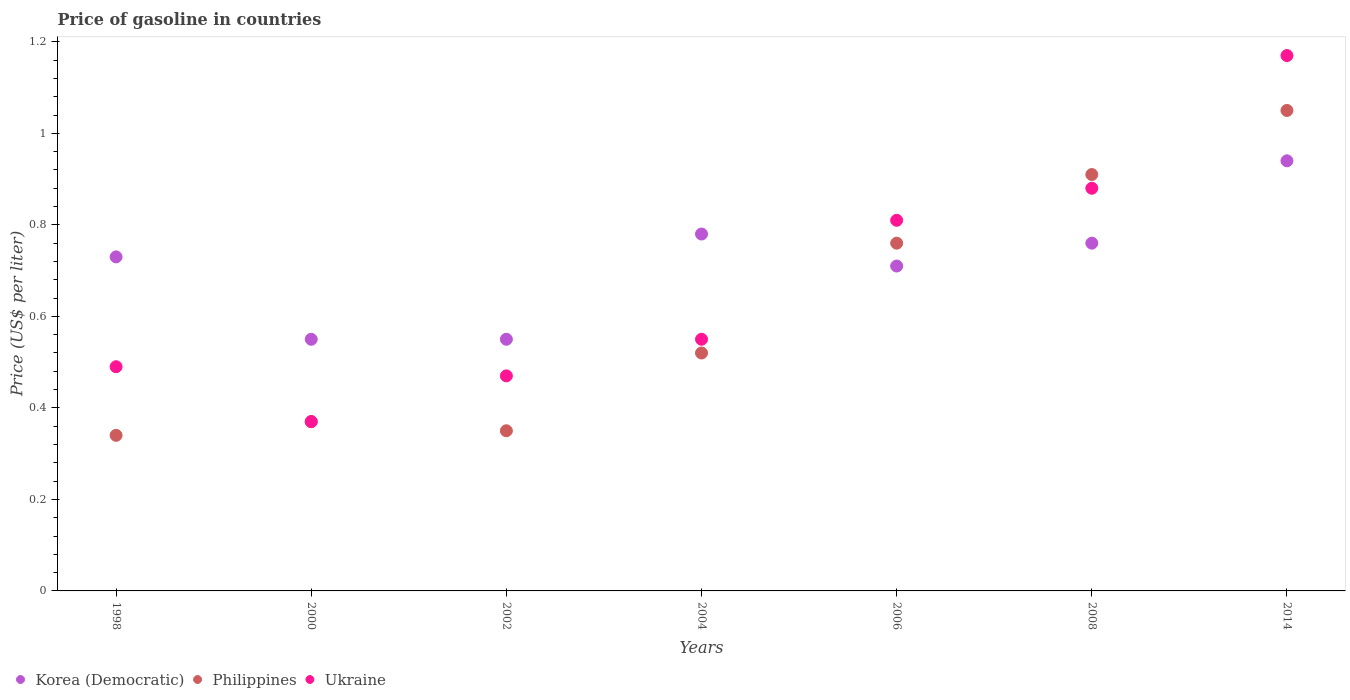How many different coloured dotlines are there?
Provide a succinct answer. 3. Is the number of dotlines equal to the number of legend labels?
Give a very brief answer. Yes. What is the price of gasoline in Korea (Democratic) in 2006?
Your answer should be very brief. 0.71. Across all years, what is the maximum price of gasoline in Philippines?
Offer a very short reply. 1.05. Across all years, what is the minimum price of gasoline in Korea (Democratic)?
Your answer should be very brief. 0.55. What is the total price of gasoline in Philippines in the graph?
Offer a very short reply. 4.3. What is the difference between the price of gasoline in Philippines in 1998 and that in 2014?
Your answer should be very brief. -0.71. What is the difference between the price of gasoline in Korea (Democratic) in 2006 and the price of gasoline in Philippines in 2008?
Provide a short and direct response. -0.2. What is the average price of gasoline in Philippines per year?
Make the answer very short. 0.61. In the year 1998, what is the difference between the price of gasoline in Philippines and price of gasoline in Korea (Democratic)?
Make the answer very short. -0.39. In how many years, is the price of gasoline in Philippines greater than 0.9600000000000001 US$?
Offer a terse response. 1. What is the ratio of the price of gasoline in Philippines in 1998 to that in 2006?
Your answer should be very brief. 0.45. What is the difference between the highest and the second highest price of gasoline in Korea (Democratic)?
Give a very brief answer. 0.16. What is the difference between the highest and the lowest price of gasoline in Korea (Democratic)?
Your response must be concise. 0.39. In how many years, is the price of gasoline in Korea (Democratic) greater than the average price of gasoline in Korea (Democratic) taken over all years?
Offer a terse response. 4. Is it the case that in every year, the sum of the price of gasoline in Ukraine and price of gasoline in Korea (Democratic)  is greater than the price of gasoline in Philippines?
Keep it short and to the point. Yes. Is the price of gasoline in Ukraine strictly less than the price of gasoline in Philippines over the years?
Offer a terse response. No. How many dotlines are there?
Your response must be concise. 3. How many years are there in the graph?
Offer a terse response. 7. What is the difference between two consecutive major ticks on the Y-axis?
Provide a short and direct response. 0.2. How are the legend labels stacked?
Offer a terse response. Horizontal. What is the title of the graph?
Give a very brief answer. Price of gasoline in countries. Does "Tanzania" appear as one of the legend labels in the graph?
Offer a very short reply. No. What is the label or title of the Y-axis?
Offer a very short reply. Price (US$ per liter). What is the Price (US$ per liter) of Korea (Democratic) in 1998?
Ensure brevity in your answer.  0.73. What is the Price (US$ per liter) of Philippines in 1998?
Offer a terse response. 0.34. What is the Price (US$ per liter) of Ukraine in 1998?
Offer a terse response. 0.49. What is the Price (US$ per liter) in Korea (Democratic) in 2000?
Your answer should be very brief. 0.55. What is the Price (US$ per liter) in Philippines in 2000?
Provide a succinct answer. 0.37. What is the Price (US$ per liter) of Ukraine in 2000?
Offer a very short reply. 0.37. What is the Price (US$ per liter) in Korea (Democratic) in 2002?
Ensure brevity in your answer.  0.55. What is the Price (US$ per liter) in Philippines in 2002?
Provide a short and direct response. 0.35. What is the Price (US$ per liter) of Ukraine in 2002?
Make the answer very short. 0.47. What is the Price (US$ per liter) in Korea (Democratic) in 2004?
Your answer should be very brief. 0.78. What is the Price (US$ per liter) of Philippines in 2004?
Your answer should be compact. 0.52. What is the Price (US$ per liter) in Ukraine in 2004?
Provide a succinct answer. 0.55. What is the Price (US$ per liter) in Korea (Democratic) in 2006?
Offer a terse response. 0.71. What is the Price (US$ per liter) of Philippines in 2006?
Offer a terse response. 0.76. What is the Price (US$ per liter) of Ukraine in 2006?
Your answer should be very brief. 0.81. What is the Price (US$ per liter) of Korea (Democratic) in 2008?
Give a very brief answer. 0.76. What is the Price (US$ per liter) in Philippines in 2008?
Ensure brevity in your answer.  0.91. What is the Price (US$ per liter) in Korea (Democratic) in 2014?
Your answer should be very brief. 0.94. What is the Price (US$ per liter) in Philippines in 2014?
Offer a very short reply. 1.05. What is the Price (US$ per liter) in Ukraine in 2014?
Provide a short and direct response. 1.17. Across all years, what is the maximum Price (US$ per liter) of Philippines?
Provide a short and direct response. 1.05. Across all years, what is the maximum Price (US$ per liter) of Ukraine?
Your response must be concise. 1.17. Across all years, what is the minimum Price (US$ per liter) in Korea (Democratic)?
Provide a succinct answer. 0.55. Across all years, what is the minimum Price (US$ per liter) of Philippines?
Keep it short and to the point. 0.34. Across all years, what is the minimum Price (US$ per liter) in Ukraine?
Offer a terse response. 0.37. What is the total Price (US$ per liter) of Korea (Democratic) in the graph?
Provide a succinct answer. 5.02. What is the total Price (US$ per liter) of Ukraine in the graph?
Make the answer very short. 4.74. What is the difference between the Price (US$ per liter) in Korea (Democratic) in 1998 and that in 2000?
Offer a very short reply. 0.18. What is the difference between the Price (US$ per liter) in Philippines in 1998 and that in 2000?
Your answer should be very brief. -0.03. What is the difference between the Price (US$ per liter) in Ukraine in 1998 and that in 2000?
Provide a short and direct response. 0.12. What is the difference between the Price (US$ per liter) of Korea (Democratic) in 1998 and that in 2002?
Your answer should be compact. 0.18. What is the difference between the Price (US$ per liter) in Philippines in 1998 and that in 2002?
Give a very brief answer. -0.01. What is the difference between the Price (US$ per liter) in Ukraine in 1998 and that in 2002?
Your response must be concise. 0.02. What is the difference between the Price (US$ per liter) in Korea (Democratic) in 1998 and that in 2004?
Give a very brief answer. -0.05. What is the difference between the Price (US$ per liter) in Philippines in 1998 and that in 2004?
Give a very brief answer. -0.18. What is the difference between the Price (US$ per liter) in Ukraine in 1998 and that in 2004?
Make the answer very short. -0.06. What is the difference between the Price (US$ per liter) in Korea (Democratic) in 1998 and that in 2006?
Offer a very short reply. 0.02. What is the difference between the Price (US$ per liter) of Philippines in 1998 and that in 2006?
Keep it short and to the point. -0.42. What is the difference between the Price (US$ per liter) of Ukraine in 1998 and that in 2006?
Offer a terse response. -0.32. What is the difference between the Price (US$ per liter) of Korea (Democratic) in 1998 and that in 2008?
Offer a terse response. -0.03. What is the difference between the Price (US$ per liter) in Philippines in 1998 and that in 2008?
Ensure brevity in your answer.  -0.57. What is the difference between the Price (US$ per liter) in Ukraine in 1998 and that in 2008?
Make the answer very short. -0.39. What is the difference between the Price (US$ per liter) of Korea (Democratic) in 1998 and that in 2014?
Provide a succinct answer. -0.21. What is the difference between the Price (US$ per liter) in Philippines in 1998 and that in 2014?
Provide a short and direct response. -0.71. What is the difference between the Price (US$ per liter) of Ukraine in 1998 and that in 2014?
Provide a succinct answer. -0.68. What is the difference between the Price (US$ per liter) of Korea (Democratic) in 2000 and that in 2002?
Ensure brevity in your answer.  0. What is the difference between the Price (US$ per liter) in Ukraine in 2000 and that in 2002?
Your response must be concise. -0.1. What is the difference between the Price (US$ per liter) in Korea (Democratic) in 2000 and that in 2004?
Make the answer very short. -0.23. What is the difference between the Price (US$ per liter) in Ukraine in 2000 and that in 2004?
Keep it short and to the point. -0.18. What is the difference between the Price (US$ per liter) in Korea (Democratic) in 2000 and that in 2006?
Provide a succinct answer. -0.16. What is the difference between the Price (US$ per liter) in Philippines in 2000 and that in 2006?
Your answer should be very brief. -0.39. What is the difference between the Price (US$ per liter) in Ukraine in 2000 and that in 2006?
Your answer should be very brief. -0.44. What is the difference between the Price (US$ per liter) of Korea (Democratic) in 2000 and that in 2008?
Your response must be concise. -0.21. What is the difference between the Price (US$ per liter) of Philippines in 2000 and that in 2008?
Give a very brief answer. -0.54. What is the difference between the Price (US$ per liter) of Ukraine in 2000 and that in 2008?
Provide a succinct answer. -0.51. What is the difference between the Price (US$ per liter) of Korea (Democratic) in 2000 and that in 2014?
Ensure brevity in your answer.  -0.39. What is the difference between the Price (US$ per liter) in Philippines in 2000 and that in 2014?
Give a very brief answer. -0.68. What is the difference between the Price (US$ per liter) of Ukraine in 2000 and that in 2014?
Your answer should be very brief. -0.8. What is the difference between the Price (US$ per liter) of Korea (Democratic) in 2002 and that in 2004?
Keep it short and to the point. -0.23. What is the difference between the Price (US$ per liter) of Philippines in 2002 and that in 2004?
Your response must be concise. -0.17. What is the difference between the Price (US$ per liter) of Ukraine in 2002 and that in 2004?
Offer a terse response. -0.08. What is the difference between the Price (US$ per liter) of Korea (Democratic) in 2002 and that in 2006?
Offer a terse response. -0.16. What is the difference between the Price (US$ per liter) in Philippines in 2002 and that in 2006?
Give a very brief answer. -0.41. What is the difference between the Price (US$ per liter) of Ukraine in 2002 and that in 2006?
Make the answer very short. -0.34. What is the difference between the Price (US$ per liter) of Korea (Democratic) in 2002 and that in 2008?
Provide a short and direct response. -0.21. What is the difference between the Price (US$ per liter) of Philippines in 2002 and that in 2008?
Ensure brevity in your answer.  -0.56. What is the difference between the Price (US$ per liter) of Ukraine in 2002 and that in 2008?
Provide a short and direct response. -0.41. What is the difference between the Price (US$ per liter) of Korea (Democratic) in 2002 and that in 2014?
Offer a very short reply. -0.39. What is the difference between the Price (US$ per liter) in Philippines in 2002 and that in 2014?
Keep it short and to the point. -0.7. What is the difference between the Price (US$ per liter) in Ukraine in 2002 and that in 2014?
Provide a succinct answer. -0.7. What is the difference between the Price (US$ per liter) of Korea (Democratic) in 2004 and that in 2006?
Provide a short and direct response. 0.07. What is the difference between the Price (US$ per liter) of Philippines in 2004 and that in 2006?
Offer a very short reply. -0.24. What is the difference between the Price (US$ per liter) in Ukraine in 2004 and that in 2006?
Keep it short and to the point. -0.26. What is the difference between the Price (US$ per liter) in Philippines in 2004 and that in 2008?
Provide a succinct answer. -0.39. What is the difference between the Price (US$ per liter) in Ukraine in 2004 and that in 2008?
Offer a terse response. -0.33. What is the difference between the Price (US$ per liter) in Korea (Democratic) in 2004 and that in 2014?
Keep it short and to the point. -0.16. What is the difference between the Price (US$ per liter) of Philippines in 2004 and that in 2014?
Give a very brief answer. -0.53. What is the difference between the Price (US$ per liter) of Ukraine in 2004 and that in 2014?
Provide a short and direct response. -0.62. What is the difference between the Price (US$ per liter) of Korea (Democratic) in 2006 and that in 2008?
Provide a short and direct response. -0.05. What is the difference between the Price (US$ per liter) of Philippines in 2006 and that in 2008?
Make the answer very short. -0.15. What is the difference between the Price (US$ per liter) of Ukraine in 2006 and that in 2008?
Ensure brevity in your answer.  -0.07. What is the difference between the Price (US$ per liter) in Korea (Democratic) in 2006 and that in 2014?
Make the answer very short. -0.23. What is the difference between the Price (US$ per liter) in Philippines in 2006 and that in 2014?
Ensure brevity in your answer.  -0.29. What is the difference between the Price (US$ per liter) in Ukraine in 2006 and that in 2014?
Keep it short and to the point. -0.36. What is the difference between the Price (US$ per liter) of Korea (Democratic) in 2008 and that in 2014?
Your answer should be very brief. -0.18. What is the difference between the Price (US$ per liter) in Philippines in 2008 and that in 2014?
Keep it short and to the point. -0.14. What is the difference between the Price (US$ per liter) of Ukraine in 2008 and that in 2014?
Your answer should be very brief. -0.29. What is the difference between the Price (US$ per liter) of Korea (Democratic) in 1998 and the Price (US$ per liter) of Philippines in 2000?
Give a very brief answer. 0.36. What is the difference between the Price (US$ per liter) of Korea (Democratic) in 1998 and the Price (US$ per liter) of Ukraine in 2000?
Your answer should be very brief. 0.36. What is the difference between the Price (US$ per liter) of Philippines in 1998 and the Price (US$ per liter) of Ukraine in 2000?
Make the answer very short. -0.03. What is the difference between the Price (US$ per liter) in Korea (Democratic) in 1998 and the Price (US$ per liter) in Philippines in 2002?
Provide a succinct answer. 0.38. What is the difference between the Price (US$ per liter) in Korea (Democratic) in 1998 and the Price (US$ per liter) in Ukraine in 2002?
Give a very brief answer. 0.26. What is the difference between the Price (US$ per liter) in Philippines in 1998 and the Price (US$ per liter) in Ukraine in 2002?
Make the answer very short. -0.13. What is the difference between the Price (US$ per liter) in Korea (Democratic) in 1998 and the Price (US$ per liter) in Philippines in 2004?
Provide a short and direct response. 0.21. What is the difference between the Price (US$ per liter) in Korea (Democratic) in 1998 and the Price (US$ per liter) in Ukraine in 2004?
Your answer should be compact. 0.18. What is the difference between the Price (US$ per liter) of Philippines in 1998 and the Price (US$ per liter) of Ukraine in 2004?
Your answer should be very brief. -0.21. What is the difference between the Price (US$ per liter) in Korea (Democratic) in 1998 and the Price (US$ per liter) in Philippines in 2006?
Make the answer very short. -0.03. What is the difference between the Price (US$ per liter) of Korea (Democratic) in 1998 and the Price (US$ per liter) of Ukraine in 2006?
Your response must be concise. -0.08. What is the difference between the Price (US$ per liter) in Philippines in 1998 and the Price (US$ per liter) in Ukraine in 2006?
Ensure brevity in your answer.  -0.47. What is the difference between the Price (US$ per liter) in Korea (Democratic) in 1998 and the Price (US$ per liter) in Philippines in 2008?
Ensure brevity in your answer.  -0.18. What is the difference between the Price (US$ per liter) of Philippines in 1998 and the Price (US$ per liter) of Ukraine in 2008?
Keep it short and to the point. -0.54. What is the difference between the Price (US$ per liter) of Korea (Democratic) in 1998 and the Price (US$ per liter) of Philippines in 2014?
Offer a very short reply. -0.32. What is the difference between the Price (US$ per liter) of Korea (Democratic) in 1998 and the Price (US$ per liter) of Ukraine in 2014?
Give a very brief answer. -0.44. What is the difference between the Price (US$ per liter) in Philippines in 1998 and the Price (US$ per liter) in Ukraine in 2014?
Make the answer very short. -0.83. What is the difference between the Price (US$ per liter) in Korea (Democratic) in 2000 and the Price (US$ per liter) in Philippines in 2002?
Your response must be concise. 0.2. What is the difference between the Price (US$ per liter) of Korea (Democratic) in 2000 and the Price (US$ per liter) of Ukraine in 2002?
Your response must be concise. 0.08. What is the difference between the Price (US$ per liter) of Philippines in 2000 and the Price (US$ per liter) of Ukraine in 2002?
Keep it short and to the point. -0.1. What is the difference between the Price (US$ per liter) in Korea (Democratic) in 2000 and the Price (US$ per liter) in Ukraine in 2004?
Give a very brief answer. 0. What is the difference between the Price (US$ per liter) of Philippines in 2000 and the Price (US$ per liter) of Ukraine in 2004?
Your answer should be very brief. -0.18. What is the difference between the Price (US$ per liter) in Korea (Democratic) in 2000 and the Price (US$ per liter) in Philippines in 2006?
Offer a very short reply. -0.21. What is the difference between the Price (US$ per liter) of Korea (Democratic) in 2000 and the Price (US$ per liter) of Ukraine in 2006?
Offer a very short reply. -0.26. What is the difference between the Price (US$ per liter) in Philippines in 2000 and the Price (US$ per liter) in Ukraine in 2006?
Give a very brief answer. -0.44. What is the difference between the Price (US$ per liter) in Korea (Democratic) in 2000 and the Price (US$ per liter) in Philippines in 2008?
Keep it short and to the point. -0.36. What is the difference between the Price (US$ per liter) of Korea (Democratic) in 2000 and the Price (US$ per liter) of Ukraine in 2008?
Make the answer very short. -0.33. What is the difference between the Price (US$ per liter) in Philippines in 2000 and the Price (US$ per liter) in Ukraine in 2008?
Offer a terse response. -0.51. What is the difference between the Price (US$ per liter) of Korea (Democratic) in 2000 and the Price (US$ per liter) of Ukraine in 2014?
Your answer should be compact. -0.62. What is the difference between the Price (US$ per liter) of Korea (Democratic) in 2002 and the Price (US$ per liter) of Philippines in 2006?
Offer a very short reply. -0.21. What is the difference between the Price (US$ per liter) of Korea (Democratic) in 2002 and the Price (US$ per liter) of Ukraine in 2006?
Provide a short and direct response. -0.26. What is the difference between the Price (US$ per liter) in Philippines in 2002 and the Price (US$ per liter) in Ukraine in 2006?
Provide a short and direct response. -0.46. What is the difference between the Price (US$ per liter) in Korea (Democratic) in 2002 and the Price (US$ per liter) in Philippines in 2008?
Provide a succinct answer. -0.36. What is the difference between the Price (US$ per liter) of Korea (Democratic) in 2002 and the Price (US$ per liter) of Ukraine in 2008?
Provide a short and direct response. -0.33. What is the difference between the Price (US$ per liter) in Philippines in 2002 and the Price (US$ per liter) in Ukraine in 2008?
Your answer should be compact. -0.53. What is the difference between the Price (US$ per liter) of Korea (Democratic) in 2002 and the Price (US$ per liter) of Ukraine in 2014?
Make the answer very short. -0.62. What is the difference between the Price (US$ per liter) in Philippines in 2002 and the Price (US$ per liter) in Ukraine in 2014?
Give a very brief answer. -0.82. What is the difference between the Price (US$ per liter) of Korea (Democratic) in 2004 and the Price (US$ per liter) of Philippines in 2006?
Give a very brief answer. 0.02. What is the difference between the Price (US$ per liter) of Korea (Democratic) in 2004 and the Price (US$ per liter) of Ukraine in 2006?
Your response must be concise. -0.03. What is the difference between the Price (US$ per liter) of Philippines in 2004 and the Price (US$ per liter) of Ukraine in 2006?
Ensure brevity in your answer.  -0.29. What is the difference between the Price (US$ per liter) in Korea (Democratic) in 2004 and the Price (US$ per liter) in Philippines in 2008?
Provide a short and direct response. -0.13. What is the difference between the Price (US$ per liter) of Korea (Democratic) in 2004 and the Price (US$ per liter) of Ukraine in 2008?
Make the answer very short. -0.1. What is the difference between the Price (US$ per liter) in Philippines in 2004 and the Price (US$ per liter) in Ukraine in 2008?
Ensure brevity in your answer.  -0.36. What is the difference between the Price (US$ per liter) in Korea (Democratic) in 2004 and the Price (US$ per liter) in Philippines in 2014?
Your answer should be very brief. -0.27. What is the difference between the Price (US$ per liter) of Korea (Democratic) in 2004 and the Price (US$ per liter) of Ukraine in 2014?
Provide a succinct answer. -0.39. What is the difference between the Price (US$ per liter) of Philippines in 2004 and the Price (US$ per liter) of Ukraine in 2014?
Provide a short and direct response. -0.65. What is the difference between the Price (US$ per liter) of Korea (Democratic) in 2006 and the Price (US$ per liter) of Ukraine in 2008?
Your answer should be very brief. -0.17. What is the difference between the Price (US$ per liter) of Philippines in 2006 and the Price (US$ per liter) of Ukraine in 2008?
Ensure brevity in your answer.  -0.12. What is the difference between the Price (US$ per liter) of Korea (Democratic) in 2006 and the Price (US$ per liter) of Philippines in 2014?
Give a very brief answer. -0.34. What is the difference between the Price (US$ per liter) in Korea (Democratic) in 2006 and the Price (US$ per liter) in Ukraine in 2014?
Give a very brief answer. -0.46. What is the difference between the Price (US$ per liter) of Philippines in 2006 and the Price (US$ per liter) of Ukraine in 2014?
Your answer should be very brief. -0.41. What is the difference between the Price (US$ per liter) in Korea (Democratic) in 2008 and the Price (US$ per liter) in Philippines in 2014?
Keep it short and to the point. -0.29. What is the difference between the Price (US$ per liter) in Korea (Democratic) in 2008 and the Price (US$ per liter) in Ukraine in 2014?
Keep it short and to the point. -0.41. What is the difference between the Price (US$ per liter) in Philippines in 2008 and the Price (US$ per liter) in Ukraine in 2014?
Your answer should be compact. -0.26. What is the average Price (US$ per liter) in Korea (Democratic) per year?
Keep it short and to the point. 0.72. What is the average Price (US$ per liter) of Philippines per year?
Provide a short and direct response. 0.61. What is the average Price (US$ per liter) in Ukraine per year?
Make the answer very short. 0.68. In the year 1998, what is the difference between the Price (US$ per liter) of Korea (Democratic) and Price (US$ per liter) of Philippines?
Provide a short and direct response. 0.39. In the year 1998, what is the difference between the Price (US$ per liter) in Korea (Democratic) and Price (US$ per liter) in Ukraine?
Offer a terse response. 0.24. In the year 1998, what is the difference between the Price (US$ per liter) of Philippines and Price (US$ per liter) of Ukraine?
Your answer should be compact. -0.15. In the year 2000, what is the difference between the Price (US$ per liter) of Korea (Democratic) and Price (US$ per liter) of Philippines?
Make the answer very short. 0.18. In the year 2000, what is the difference between the Price (US$ per liter) in Korea (Democratic) and Price (US$ per liter) in Ukraine?
Keep it short and to the point. 0.18. In the year 2000, what is the difference between the Price (US$ per liter) of Philippines and Price (US$ per liter) of Ukraine?
Your answer should be very brief. 0. In the year 2002, what is the difference between the Price (US$ per liter) of Korea (Democratic) and Price (US$ per liter) of Philippines?
Your answer should be very brief. 0.2. In the year 2002, what is the difference between the Price (US$ per liter) in Korea (Democratic) and Price (US$ per liter) in Ukraine?
Offer a terse response. 0.08. In the year 2002, what is the difference between the Price (US$ per liter) in Philippines and Price (US$ per liter) in Ukraine?
Ensure brevity in your answer.  -0.12. In the year 2004, what is the difference between the Price (US$ per liter) of Korea (Democratic) and Price (US$ per liter) of Philippines?
Your answer should be very brief. 0.26. In the year 2004, what is the difference between the Price (US$ per liter) in Korea (Democratic) and Price (US$ per liter) in Ukraine?
Your answer should be compact. 0.23. In the year 2004, what is the difference between the Price (US$ per liter) in Philippines and Price (US$ per liter) in Ukraine?
Provide a short and direct response. -0.03. In the year 2006, what is the difference between the Price (US$ per liter) in Korea (Democratic) and Price (US$ per liter) in Philippines?
Keep it short and to the point. -0.05. In the year 2006, what is the difference between the Price (US$ per liter) in Philippines and Price (US$ per liter) in Ukraine?
Make the answer very short. -0.05. In the year 2008, what is the difference between the Price (US$ per liter) in Korea (Democratic) and Price (US$ per liter) in Ukraine?
Offer a very short reply. -0.12. In the year 2014, what is the difference between the Price (US$ per liter) of Korea (Democratic) and Price (US$ per liter) of Philippines?
Your answer should be compact. -0.11. In the year 2014, what is the difference between the Price (US$ per liter) in Korea (Democratic) and Price (US$ per liter) in Ukraine?
Ensure brevity in your answer.  -0.23. In the year 2014, what is the difference between the Price (US$ per liter) in Philippines and Price (US$ per liter) in Ukraine?
Your response must be concise. -0.12. What is the ratio of the Price (US$ per liter) of Korea (Democratic) in 1998 to that in 2000?
Provide a succinct answer. 1.33. What is the ratio of the Price (US$ per liter) in Philippines in 1998 to that in 2000?
Offer a terse response. 0.92. What is the ratio of the Price (US$ per liter) in Ukraine in 1998 to that in 2000?
Keep it short and to the point. 1.32. What is the ratio of the Price (US$ per liter) in Korea (Democratic) in 1998 to that in 2002?
Provide a short and direct response. 1.33. What is the ratio of the Price (US$ per liter) of Philippines in 1998 to that in 2002?
Your answer should be compact. 0.97. What is the ratio of the Price (US$ per liter) of Ukraine in 1998 to that in 2002?
Offer a very short reply. 1.04. What is the ratio of the Price (US$ per liter) of Korea (Democratic) in 1998 to that in 2004?
Keep it short and to the point. 0.94. What is the ratio of the Price (US$ per liter) of Philippines in 1998 to that in 2004?
Make the answer very short. 0.65. What is the ratio of the Price (US$ per liter) in Ukraine in 1998 to that in 2004?
Your response must be concise. 0.89. What is the ratio of the Price (US$ per liter) of Korea (Democratic) in 1998 to that in 2006?
Offer a very short reply. 1.03. What is the ratio of the Price (US$ per liter) in Philippines in 1998 to that in 2006?
Offer a terse response. 0.45. What is the ratio of the Price (US$ per liter) in Ukraine in 1998 to that in 2006?
Make the answer very short. 0.6. What is the ratio of the Price (US$ per liter) of Korea (Democratic) in 1998 to that in 2008?
Your answer should be very brief. 0.96. What is the ratio of the Price (US$ per liter) of Philippines in 1998 to that in 2008?
Give a very brief answer. 0.37. What is the ratio of the Price (US$ per liter) of Ukraine in 1998 to that in 2008?
Your answer should be very brief. 0.56. What is the ratio of the Price (US$ per liter) in Korea (Democratic) in 1998 to that in 2014?
Provide a succinct answer. 0.78. What is the ratio of the Price (US$ per liter) in Philippines in 1998 to that in 2014?
Your answer should be very brief. 0.32. What is the ratio of the Price (US$ per liter) of Ukraine in 1998 to that in 2014?
Provide a short and direct response. 0.42. What is the ratio of the Price (US$ per liter) in Korea (Democratic) in 2000 to that in 2002?
Provide a succinct answer. 1. What is the ratio of the Price (US$ per liter) of Philippines in 2000 to that in 2002?
Provide a short and direct response. 1.06. What is the ratio of the Price (US$ per liter) of Ukraine in 2000 to that in 2002?
Keep it short and to the point. 0.79. What is the ratio of the Price (US$ per liter) of Korea (Democratic) in 2000 to that in 2004?
Keep it short and to the point. 0.71. What is the ratio of the Price (US$ per liter) of Philippines in 2000 to that in 2004?
Provide a succinct answer. 0.71. What is the ratio of the Price (US$ per liter) in Ukraine in 2000 to that in 2004?
Your response must be concise. 0.67. What is the ratio of the Price (US$ per liter) of Korea (Democratic) in 2000 to that in 2006?
Keep it short and to the point. 0.77. What is the ratio of the Price (US$ per liter) in Philippines in 2000 to that in 2006?
Your answer should be compact. 0.49. What is the ratio of the Price (US$ per liter) in Ukraine in 2000 to that in 2006?
Make the answer very short. 0.46. What is the ratio of the Price (US$ per liter) of Korea (Democratic) in 2000 to that in 2008?
Offer a very short reply. 0.72. What is the ratio of the Price (US$ per liter) in Philippines in 2000 to that in 2008?
Offer a terse response. 0.41. What is the ratio of the Price (US$ per liter) of Ukraine in 2000 to that in 2008?
Your answer should be very brief. 0.42. What is the ratio of the Price (US$ per liter) of Korea (Democratic) in 2000 to that in 2014?
Keep it short and to the point. 0.59. What is the ratio of the Price (US$ per liter) in Philippines in 2000 to that in 2014?
Ensure brevity in your answer.  0.35. What is the ratio of the Price (US$ per liter) of Ukraine in 2000 to that in 2014?
Ensure brevity in your answer.  0.32. What is the ratio of the Price (US$ per liter) of Korea (Democratic) in 2002 to that in 2004?
Keep it short and to the point. 0.71. What is the ratio of the Price (US$ per liter) in Philippines in 2002 to that in 2004?
Offer a very short reply. 0.67. What is the ratio of the Price (US$ per liter) of Ukraine in 2002 to that in 2004?
Make the answer very short. 0.85. What is the ratio of the Price (US$ per liter) of Korea (Democratic) in 2002 to that in 2006?
Your answer should be compact. 0.77. What is the ratio of the Price (US$ per liter) in Philippines in 2002 to that in 2006?
Your response must be concise. 0.46. What is the ratio of the Price (US$ per liter) in Ukraine in 2002 to that in 2006?
Your response must be concise. 0.58. What is the ratio of the Price (US$ per liter) in Korea (Democratic) in 2002 to that in 2008?
Ensure brevity in your answer.  0.72. What is the ratio of the Price (US$ per liter) in Philippines in 2002 to that in 2008?
Your response must be concise. 0.38. What is the ratio of the Price (US$ per liter) in Ukraine in 2002 to that in 2008?
Your answer should be very brief. 0.53. What is the ratio of the Price (US$ per liter) of Korea (Democratic) in 2002 to that in 2014?
Your answer should be compact. 0.59. What is the ratio of the Price (US$ per liter) of Philippines in 2002 to that in 2014?
Provide a short and direct response. 0.33. What is the ratio of the Price (US$ per liter) of Ukraine in 2002 to that in 2014?
Provide a succinct answer. 0.4. What is the ratio of the Price (US$ per liter) in Korea (Democratic) in 2004 to that in 2006?
Make the answer very short. 1.1. What is the ratio of the Price (US$ per liter) of Philippines in 2004 to that in 2006?
Give a very brief answer. 0.68. What is the ratio of the Price (US$ per liter) of Ukraine in 2004 to that in 2006?
Offer a terse response. 0.68. What is the ratio of the Price (US$ per liter) of Korea (Democratic) in 2004 to that in 2008?
Offer a terse response. 1.03. What is the ratio of the Price (US$ per liter) of Philippines in 2004 to that in 2008?
Your answer should be compact. 0.57. What is the ratio of the Price (US$ per liter) of Ukraine in 2004 to that in 2008?
Your answer should be compact. 0.62. What is the ratio of the Price (US$ per liter) of Korea (Democratic) in 2004 to that in 2014?
Offer a terse response. 0.83. What is the ratio of the Price (US$ per liter) of Philippines in 2004 to that in 2014?
Offer a very short reply. 0.5. What is the ratio of the Price (US$ per liter) of Ukraine in 2004 to that in 2014?
Provide a succinct answer. 0.47. What is the ratio of the Price (US$ per liter) of Korea (Democratic) in 2006 to that in 2008?
Provide a short and direct response. 0.93. What is the ratio of the Price (US$ per liter) in Philippines in 2006 to that in 2008?
Offer a terse response. 0.84. What is the ratio of the Price (US$ per liter) in Ukraine in 2006 to that in 2008?
Provide a succinct answer. 0.92. What is the ratio of the Price (US$ per liter) of Korea (Democratic) in 2006 to that in 2014?
Your answer should be compact. 0.76. What is the ratio of the Price (US$ per liter) in Philippines in 2006 to that in 2014?
Give a very brief answer. 0.72. What is the ratio of the Price (US$ per liter) in Ukraine in 2006 to that in 2014?
Your answer should be very brief. 0.69. What is the ratio of the Price (US$ per liter) in Korea (Democratic) in 2008 to that in 2014?
Your response must be concise. 0.81. What is the ratio of the Price (US$ per liter) of Philippines in 2008 to that in 2014?
Your answer should be compact. 0.87. What is the ratio of the Price (US$ per liter) of Ukraine in 2008 to that in 2014?
Your answer should be very brief. 0.75. What is the difference between the highest and the second highest Price (US$ per liter) in Korea (Democratic)?
Offer a very short reply. 0.16. What is the difference between the highest and the second highest Price (US$ per liter) in Philippines?
Keep it short and to the point. 0.14. What is the difference between the highest and the second highest Price (US$ per liter) of Ukraine?
Your answer should be very brief. 0.29. What is the difference between the highest and the lowest Price (US$ per liter) in Korea (Democratic)?
Your response must be concise. 0.39. What is the difference between the highest and the lowest Price (US$ per liter) in Philippines?
Your response must be concise. 0.71. What is the difference between the highest and the lowest Price (US$ per liter) in Ukraine?
Provide a short and direct response. 0.8. 